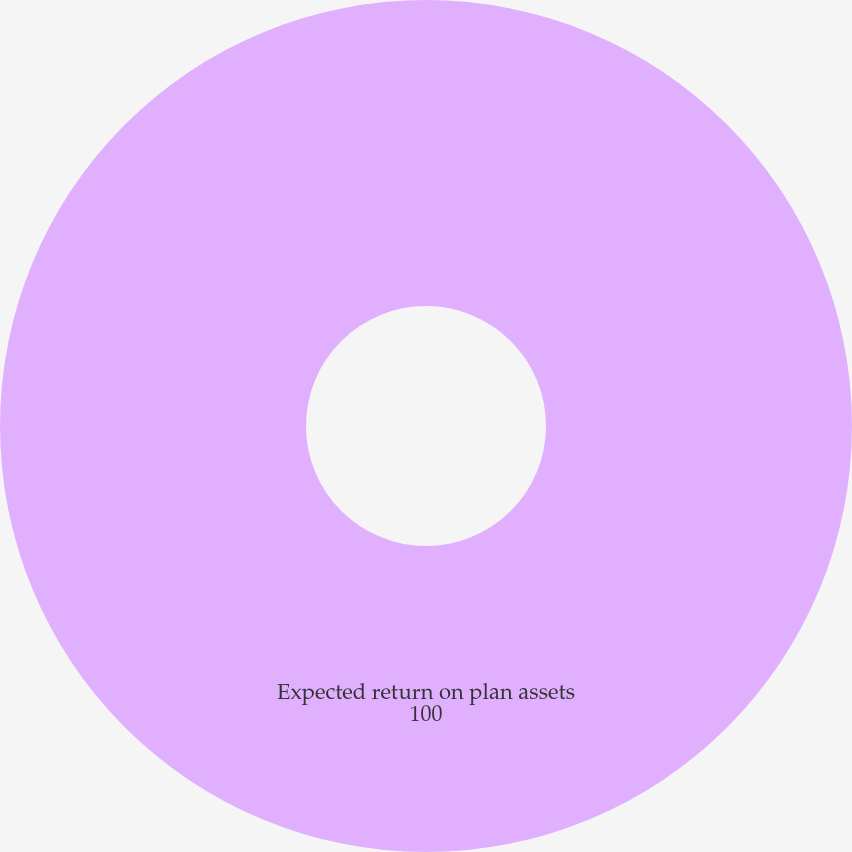<chart> <loc_0><loc_0><loc_500><loc_500><pie_chart><fcel>Expected return on plan assets<nl><fcel>100.0%<nl></chart> 